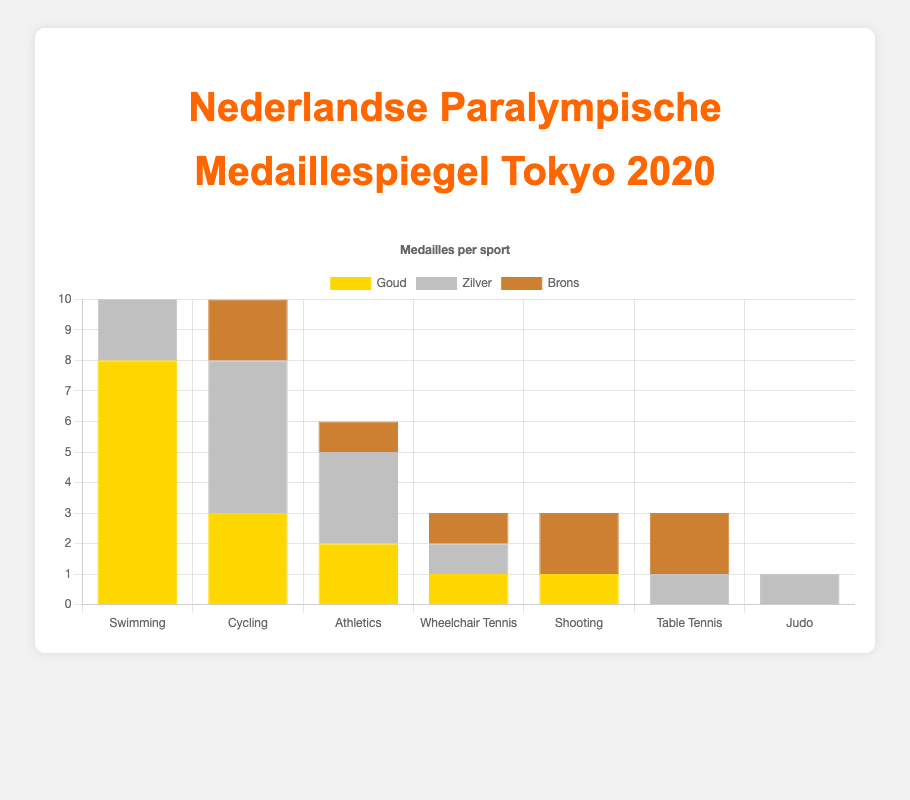How many total medals did the Dutch Paralympic athletes win in Swimming? To find the total medals in Swimming, sum the gold, silver, and bronze medals. 8 (gold) + 4 (silver) + 3 (bronze) = 15
Answer: 15 Which sport awarded the most gold medals to Dutch athletes? By examining the gold bars, Swimming has the tallest bar with 8 gold medals, which is the highest
Answer: Swimming Between Cycling and Athletics, which sport had more total medals, and what is the difference? Calculate the total medals for each: Cycling has 3 (gold) + 5 (silver) + 2 (bronze) = 10. Athletics has 2 (gold) + 3 (silver) + 1 (bronze) = 6. The difference is 10 - 6 = 4
Answer: Cycling, 4 How many silver medals did Dutch athletes win in total across all sports? Sum the silver medals from all sports: 4 (Swimming) + 5 (Cycling) + 3 (Athletics) + 1 (Wheelchair Tennis) + 0 (Shooting) + 1 (Table Tennis) + 1 (Judo) = 15
Answer: 15 In which sports did Dutch athletes win exactly 1 bronze medal? Look at the bronze bars, Athletics and Wheelchair Tennis each have 1 bronze medal based on the bar heights
Answer: Athletics, Wheelchair Tennis Compare the total number of medals won in Wheelchair Tennis and Shooting. Which has more, and by how much? Wheelchair Tennis has 1 (gold) + 1 (silver) + 1 (bronze) = 3, while Shooting has 1 (gold) + 0 (silver) + 2 (bronze) = 3. Both sports have the same tally
Answer: Both have the same, 0 What is the total number of gold and silver medals combined in Table Tennis? Table Tennis has 0 gold medals and 1 silver medal. Combined, this equals 0 + 1 = 1
Answer: 1 How many more gold medals did Dutch athletes win in Swimming compared to Cycling? Swimming has 8 gold medals, and Cycling has 3. The difference is 8 - 3 = 5
Answer: 5 Calculate the total number of bronze medals won by Dutch athletes across all sports. Sum the bronze medals: 3 (Swimming) + 2 (Cycling) + 1 (Athletics) + 1 (Wheelchair Tennis) + 2 (Shooting) + 2 (Table Tennis) + 0 (Judo) = 11
Answer: 11 